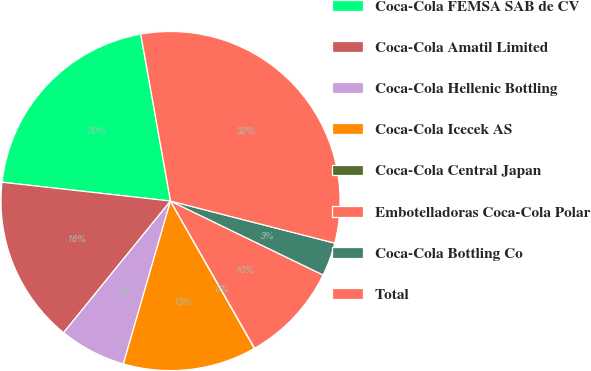<chart> <loc_0><loc_0><loc_500><loc_500><pie_chart><fcel>Coca-Cola FEMSA SAB de CV<fcel>Coca-Cola Amatil Limited<fcel>Coca-Cola Hellenic Bottling<fcel>Coca-Cola Icecek AS<fcel>Coca-Cola Central Japan<fcel>Embotelladoras Coca-Cola Polar<fcel>Coca-Cola Bottling Co<fcel>Total<nl><fcel>20.42%<fcel>15.91%<fcel>6.37%<fcel>12.73%<fcel>0.02%<fcel>9.55%<fcel>3.19%<fcel>31.8%<nl></chart> 